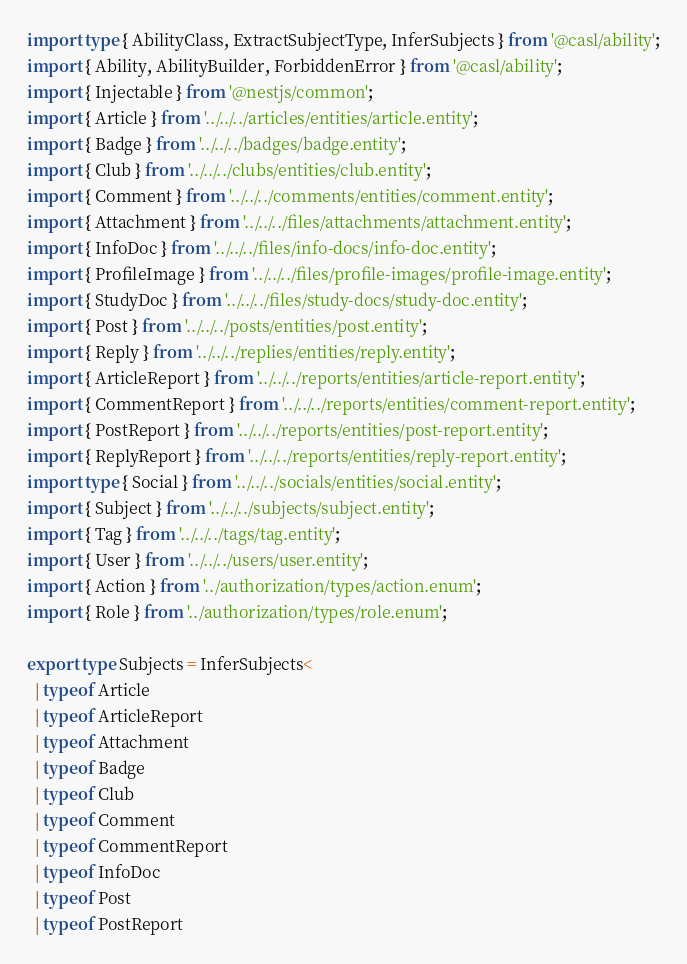<code> <loc_0><loc_0><loc_500><loc_500><_TypeScript_>import type { AbilityClass, ExtractSubjectType, InferSubjects } from '@casl/ability';
import { Ability, AbilityBuilder, ForbiddenError } from '@casl/ability';
import { Injectable } from '@nestjs/common';
import { Article } from '../../../articles/entities/article.entity';
import { Badge } from '../../../badges/badge.entity';
import { Club } from '../../../clubs/entities/club.entity';
import { Comment } from '../../../comments/entities/comment.entity';
import { Attachment } from '../../../files/attachments/attachment.entity';
import { InfoDoc } from '../../../files/info-docs/info-doc.entity';
import { ProfileImage } from '../../../files/profile-images/profile-image.entity';
import { StudyDoc } from '../../../files/study-docs/study-doc.entity';
import { Post } from '../../../posts/entities/post.entity';
import { Reply } from '../../../replies/entities/reply.entity';
import { ArticleReport } from '../../../reports/entities/article-report.entity';
import { CommentReport } from '../../../reports/entities/comment-report.entity';
import { PostReport } from '../../../reports/entities/post-report.entity';
import { ReplyReport } from '../../../reports/entities/reply-report.entity';
import type { Social } from '../../../socials/entities/social.entity';
import { Subject } from '../../../subjects/subject.entity';
import { Tag } from '../../../tags/tag.entity';
import { User } from '../../../users/user.entity';
import { Action } from '../authorization/types/action.enum';
import { Role } from '../authorization/types/role.enum';

export type Subjects = InferSubjects<
  | typeof Article
  | typeof ArticleReport
  | typeof Attachment
  | typeof Badge
  | typeof Club
  | typeof Comment
  | typeof CommentReport
  | typeof InfoDoc
  | typeof Post
  | typeof PostReport</code> 